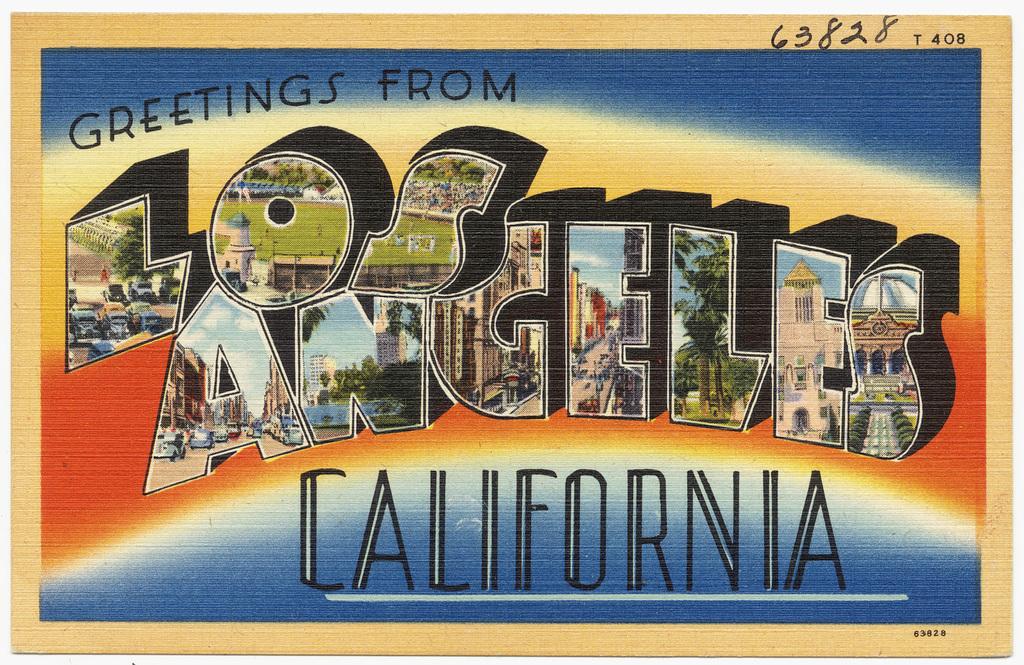What city in california is this from?
Your answer should be very brief. Los angeles. Where is the greeting coming from?
Offer a very short reply. California. 